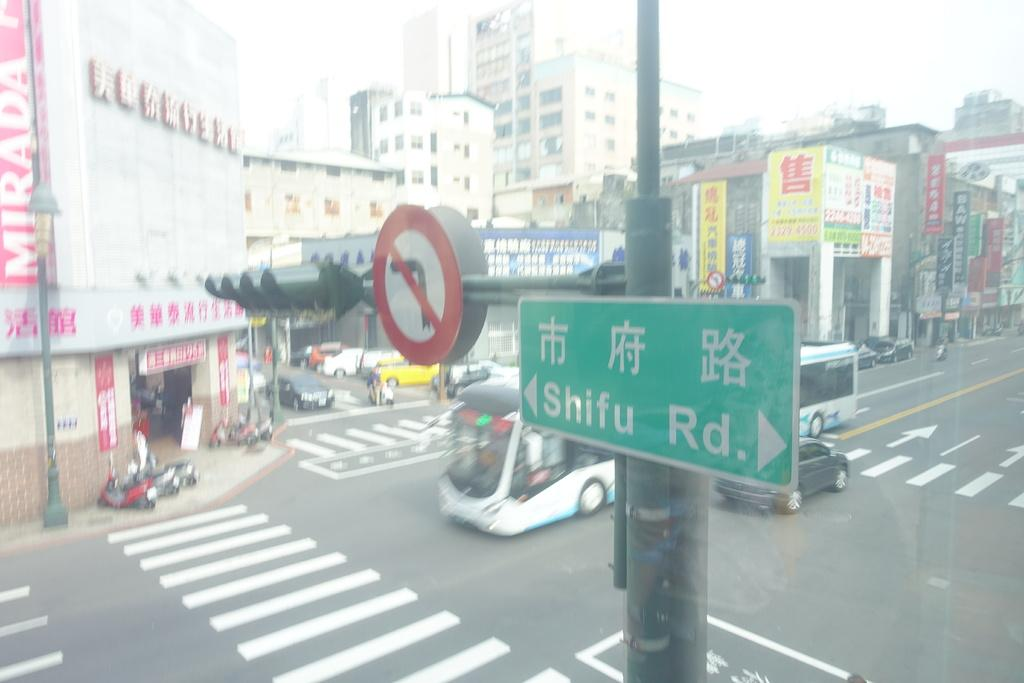<image>
Provide a brief description of the given image. A green street sign is labeled Shifu Rd and has an arrow pointing to the left. 